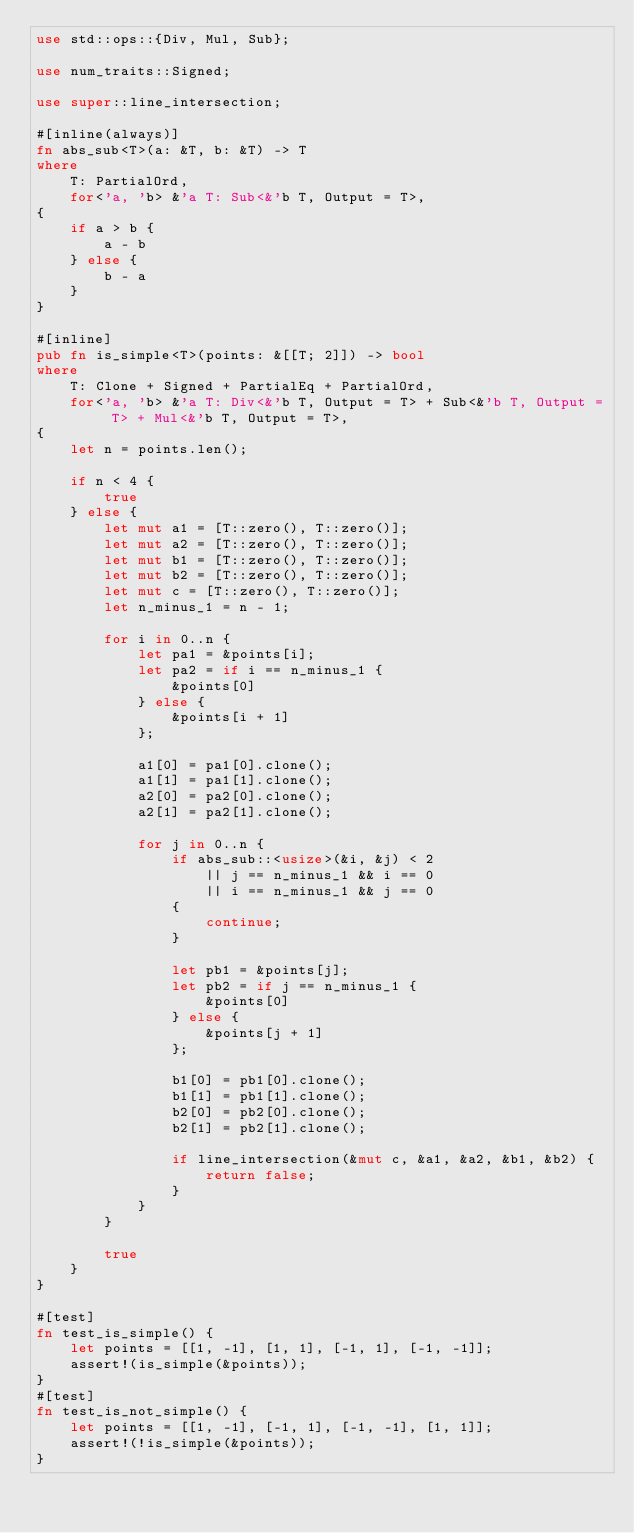<code> <loc_0><loc_0><loc_500><loc_500><_Rust_>use std::ops::{Div, Mul, Sub};

use num_traits::Signed;

use super::line_intersection;

#[inline(always)]
fn abs_sub<T>(a: &T, b: &T) -> T
where
    T: PartialOrd,
    for<'a, 'b> &'a T: Sub<&'b T, Output = T>,
{
    if a > b {
        a - b
    } else {
        b - a
    }
}

#[inline]
pub fn is_simple<T>(points: &[[T; 2]]) -> bool
where
    T: Clone + Signed + PartialEq + PartialOrd,
    for<'a, 'b> &'a T: Div<&'b T, Output = T> + Sub<&'b T, Output = T> + Mul<&'b T, Output = T>,
{
    let n = points.len();

    if n < 4 {
        true
    } else {
        let mut a1 = [T::zero(), T::zero()];
        let mut a2 = [T::zero(), T::zero()];
        let mut b1 = [T::zero(), T::zero()];
        let mut b2 = [T::zero(), T::zero()];
        let mut c = [T::zero(), T::zero()];
        let n_minus_1 = n - 1;

        for i in 0..n {
            let pa1 = &points[i];
            let pa2 = if i == n_minus_1 {
                &points[0]
            } else {
                &points[i + 1]
            };

            a1[0] = pa1[0].clone();
            a1[1] = pa1[1].clone();
            a2[0] = pa2[0].clone();
            a2[1] = pa2[1].clone();

            for j in 0..n {
                if abs_sub::<usize>(&i, &j) < 2
                    || j == n_minus_1 && i == 0
                    || i == n_minus_1 && j == 0
                {
                    continue;
                }

                let pb1 = &points[j];
                let pb2 = if j == n_minus_1 {
                    &points[0]
                } else {
                    &points[j + 1]
                };

                b1[0] = pb1[0].clone();
                b1[1] = pb1[1].clone();
                b2[0] = pb2[0].clone();
                b2[1] = pb2[1].clone();

                if line_intersection(&mut c, &a1, &a2, &b1, &b2) {
                    return false;
                }
            }
        }

        true
    }
}

#[test]
fn test_is_simple() {
    let points = [[1, -1], [1, 1], [-1, 1], [-1, -1]];
    assert!(is_simple(&points));
}
#[test]
fn test_is_not_simple() {
    let points = [[1, -1], [-1, 1], [-1, -1], [1, 1]];
    assert!(!is_simple(&points));
}
</code> 